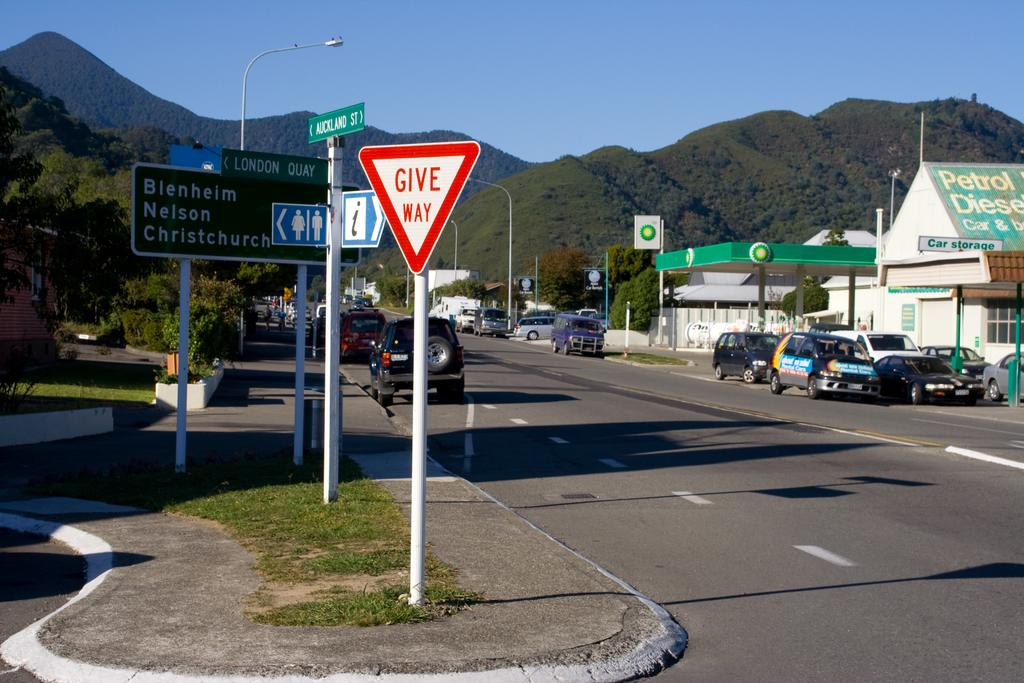What can be seen on the road in the image? There are vehicles on the road in the image. What type of structures are present in the image? There are houses in the image. What are the vertical structures in the image? There are poles in the image. What type of information is displayed in the image? There are signboards in the image. What type of vegetation is present in the image? There are plants and trees in the image. What natural feature is visible in the background of the image? There are mountains in the image. What is visible in the sky in the image? The sky is visible in the background of the image. What is the plot of the fiction story depicted in the image? There is no fiction story depicted in the image; it is a photograph of a scene with vehicles, houses, poles, signboards, plants, trees, mountains, and the sky. How does the sleet affect the visibility of the vehicles on the road in the image? There is no mention of sleet in the image; it is a clear day with vehicles on the road. 